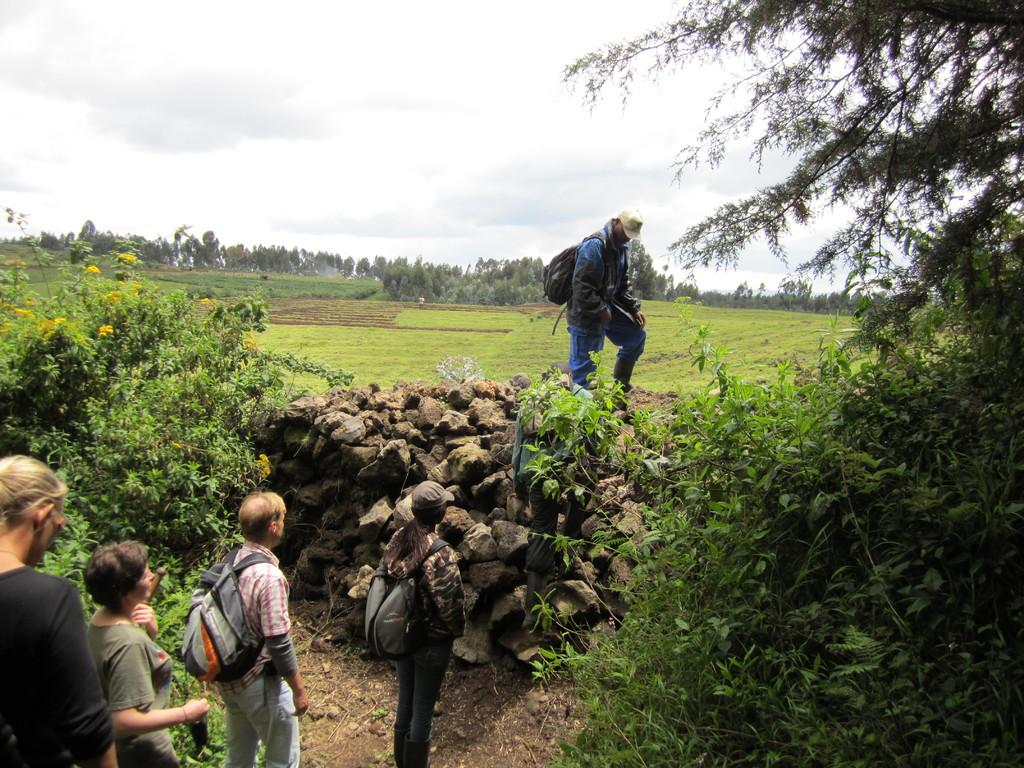Where was the image taken? The image was taken in a field. What can be seen in the foreground of the picture? There are trees, stones, and people in the foreground of the picture. What else is present in the foreground of the picture? There is also sand in the foreground of the picture. What is visible in the center of the picture? There are fields and trees in the center of the picture. How would you describe the sky in the image? The sky is cloudy. What type of drug is being sold in the image? There is no indication of any drug being sold or present in the image. What type of voyage are the people in the image embarking on? There is no indication of any voyage or journey in the image. 